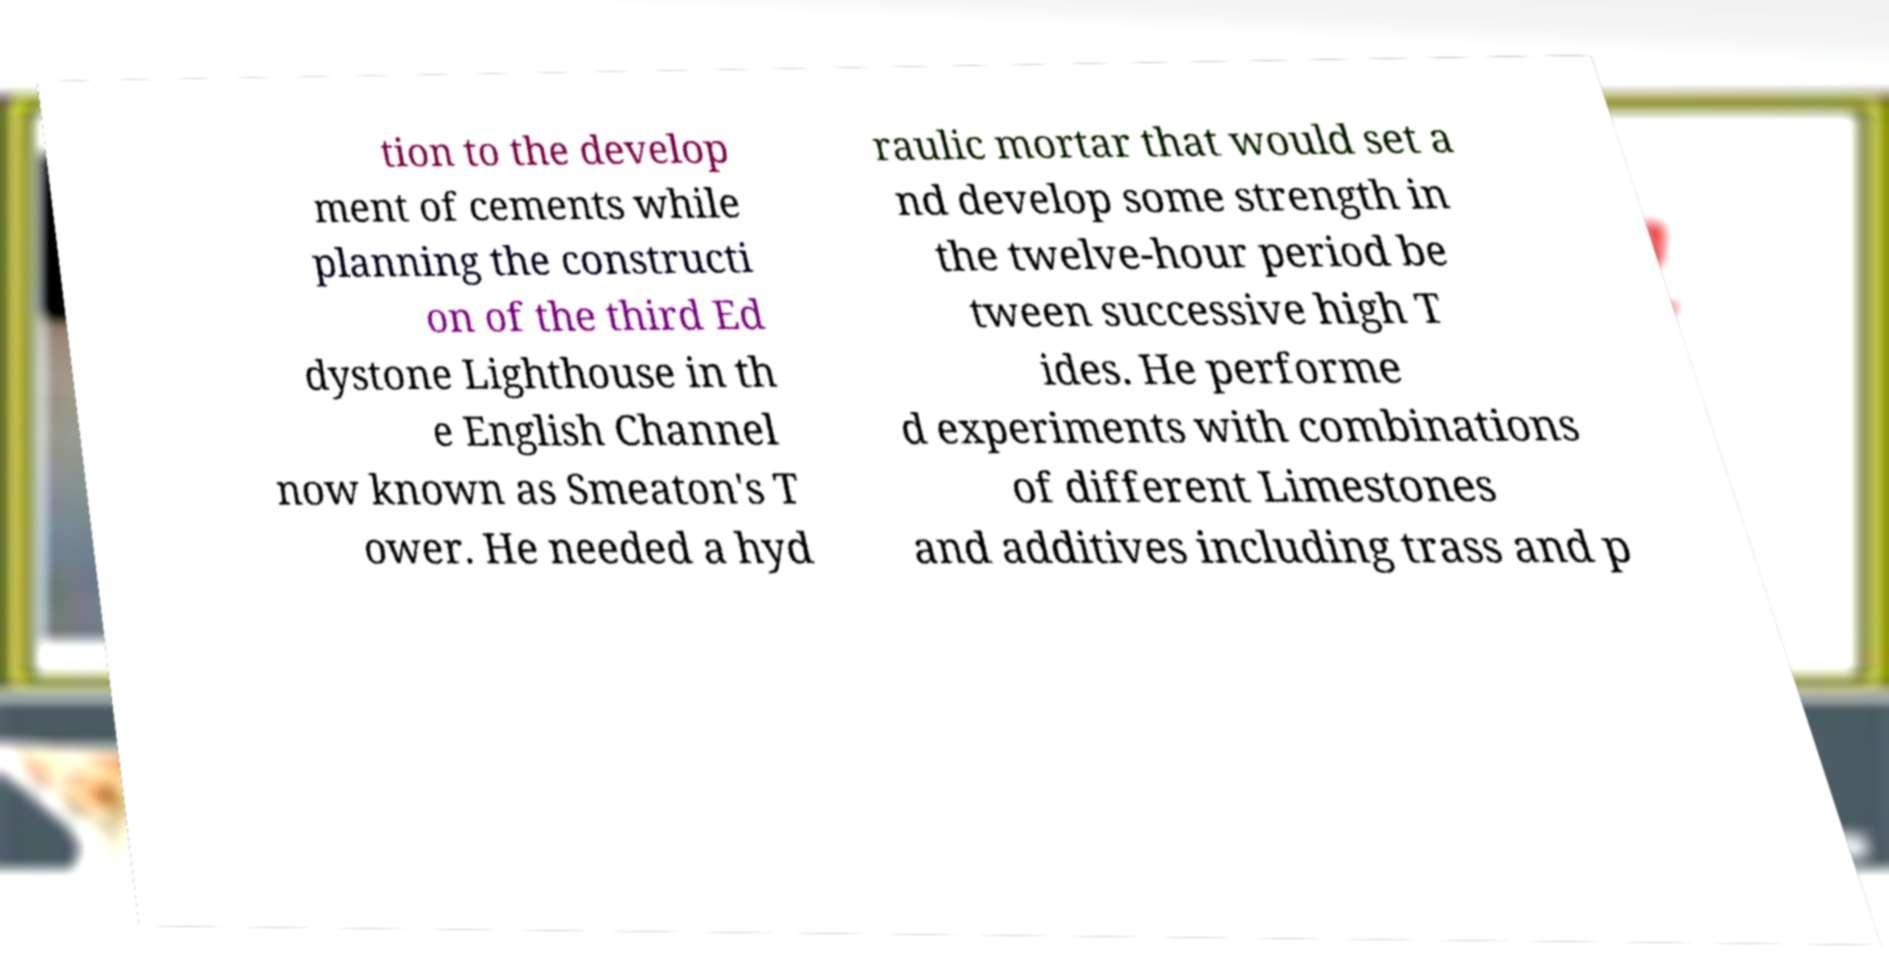For documentation purposes, I need the text within this image transcribed. Could you provide that? tion to the develop ment of cements while planning the constructi on of the third Ed dystone Lighthouse in th e English Channel now known as Smeaton's T ower. He needed a hyd raulic mortar that would set a nd develop some strength in the twelve-hour period be tween successive high T ides. He performe d experiments with combinations of different Limestones and additives including trass and p 